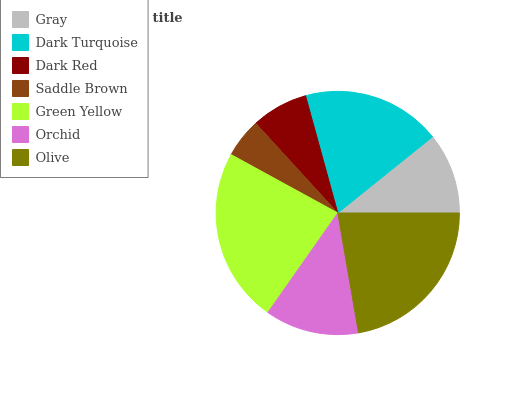Is Saddle Brown the minimum?
Answer yes or no. Yes. Is Green Yellow the maximum?
Answer yes or no. Yes. Is Dark Turquoise the minimum?
Answer yes or no. No. Is Dark Turquoise the maximum?
Answer yes or no. No. Is Dark Turquoise greater than Gray?
Answer yes or no. Yes. Is Gray less than Dark Turquoise?
Answer yes or no. Yes. Is Gray greater than Dark Turquoise?
Answer yes or no. No. Is Dark Turquoise less than Gray?
Answer yes or no. No. Is Orchid the high median?
Answer yes or no. Yes. Is Orchid the low median?
Answer yes or no. Yes. Is Olive the high median?
Answer yes or no. No. Is Olive the low median?
Answer yes or no. No. 